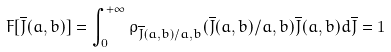<formula> <loc_0><loc_0><loc_500><loc_500>F [ \overline { J } ( a , b ) ] = \int _ { 0 } ^ { + \infty } \rho _ { \overline { J } ( a , b ) / a , b } ( \overline { J } ( a , b ) / a , b ) \overline { J } ( a , b ) d \overline { J } = 1</formula> 